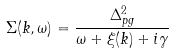<formula> <loc_0><loc_0><loc_500><loc_500>\Sigma ( { k } , \omega ) = \frac { \Delta _ { p g } ^ { 2 } } { \omega + \xi ( { k } ) + i \gamma }</formula> 